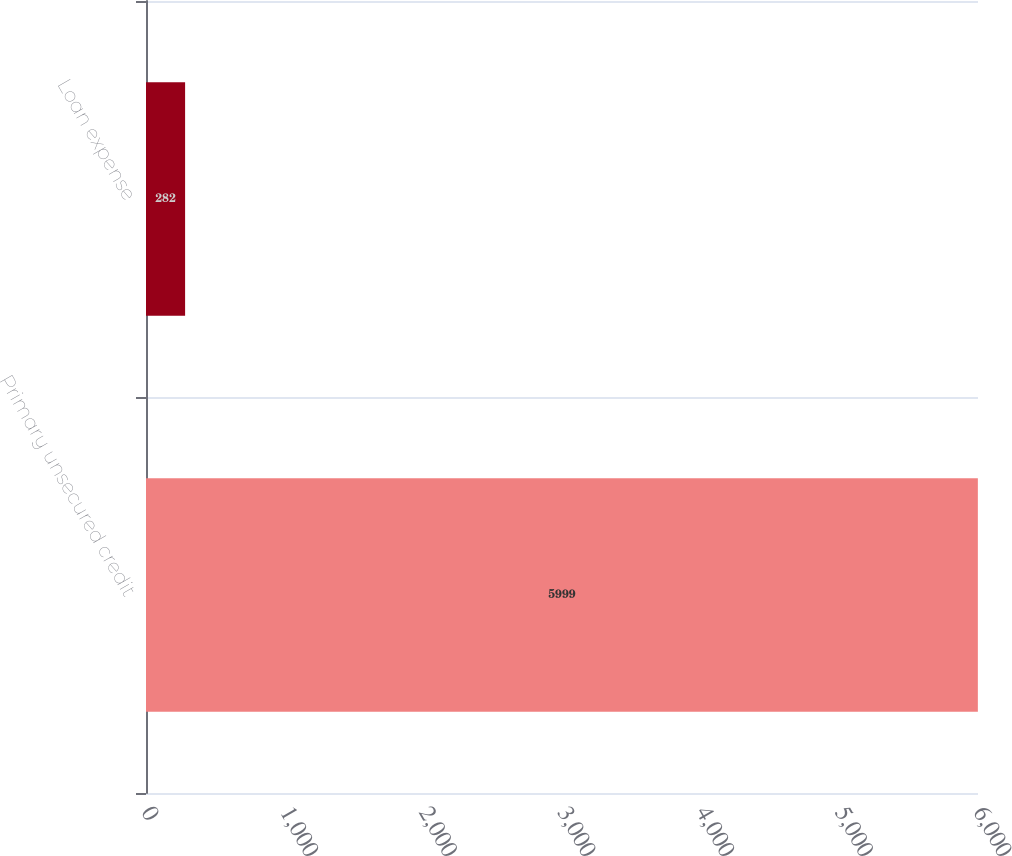<chart> <loc_0><loc_0><loc_500><loc_500><bar_chart><fcel>Primary unsecured credit<fcel>Loan expense<nl><fcel>5999<fcel>282<nl></chart> 